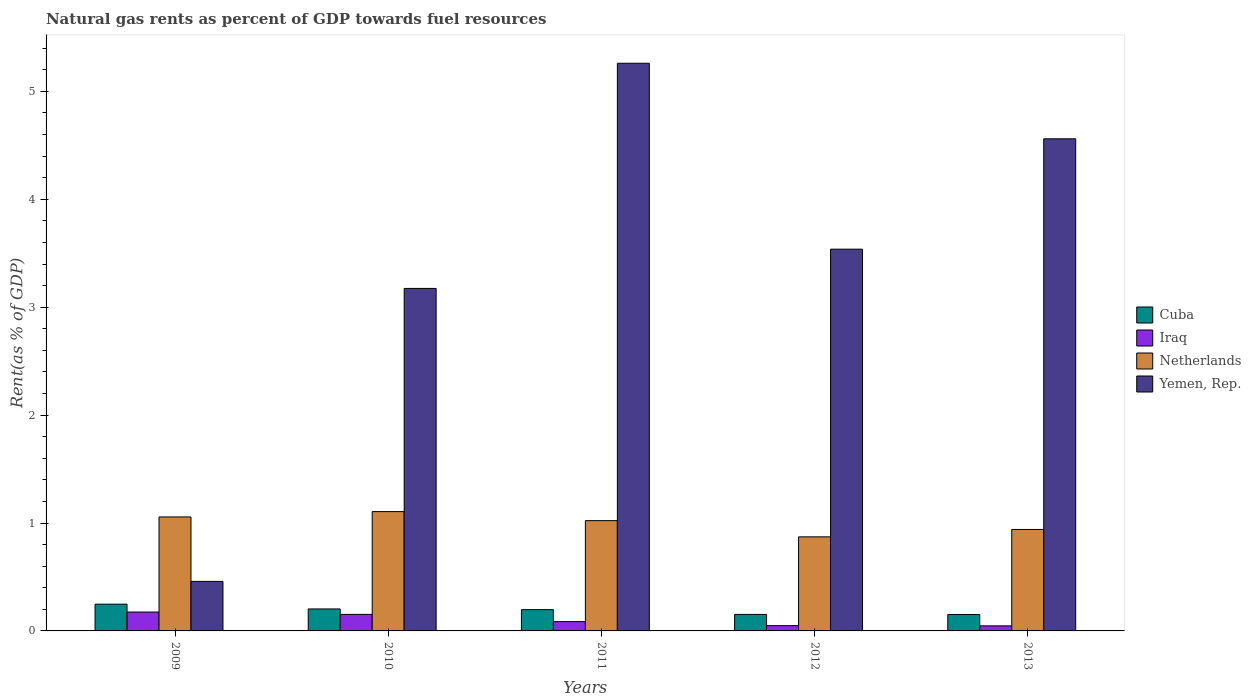How many different coloured bars are there?
Give a very brief answer. 4. How many groups of bars are there?
Ensure brevity in your answer.  5. How many bars are there on the 1st tick from the left?
Your answer should be compact. 4. How many bars are there on the 1st tick from the right?
Your answer should be compact. 4. What is the matural gas rent in Yemen, Rep. in 2011?
Ensure brevity in your answer.  5.26. Across all years, what is the maximum matural gas rent in Yemen, Rep.?
Offer a terse response. 5.26. Across all years, what is the minimum matural gas rent in Netherlands?
Your response must be concise. 0.87. In which year was the matural gas rent in Iraq maximum?
Keep it short and to the point. 2009. What is the total matural gas rent in Yemen, Rep. in the graph?
Ensure brevity in your answer.  16.99. What is the difference between the matural gas rent in Cuba in 2010 and that in 2011?
Offer a very short reply. 0.01. What is the difference between the matural gas rent in Yemen, Rep. in 2009 and the matural gas rent in Netherlands in 2013?
Offer a terse response. -0.48. What is the average matural gas rent in Iraq per year?
Offer a very short reply. 0.1. In the year 2010, what is the difference between the matural gas rent in Iraq and matural gas rent in Netherlands?
Provide a succinct answer. -0.95. In how many years, is the matural gas rent in Yemen, Rep. greater than 1.6 %?
Ensure brevity in your answer.  4. What is the ratio of the matural gas rent in Cuba in 2010 to that in 2013?
Your answer should be compact. 1.34. Is the matural gas rent in Netherlands in 2009 less than that in 2011?
Your response must be concise. No. What is the difference between the highest and the second highest matural gas rent in Netherlands?
Your answer should be compact. 0.05. What is the difference between the highest and the lowest matural gas rent in Netherlands?
Your response must be concise. 0.23. Is the sum of the matural gas rent in Iraq in 2011 and 2012 greater than the maximum matural gas rent in Yemen, Rep. across all years?
Give a very brief answer. No. Is it the case that in every year, the sum of the matural gas rent in Netherlands and matural gas rent in Iraq is greater than the sum of matural gas rent in Cuba and matural gas rent in Yemen, Rep.?
Your answer should be compact. No. What does the 1st bar from the left in 2009 represents?
Your answer should be very brief. Cuba. What does the 1st bar from the right in 2013 represents?
Give a very brief answer. Yemen, Rep. Is it the case that in every year, the sum of the matural gas rent in Iraq and matural gas rent in Cuba is greater than the matural gas rent in Yemen, Rep.?
Make the answer very short. No. Are all the bars in the graph horizontal?
Offer a very short reply. No. How many years are there in the graph?
Keep it short and to the point. 5. Are the values on the major ticks of Y-axis written in scientific E-notation?
Ensure brevity in your answer.  No. Where does the legend appear in the graph?
Keep it short and to the point. Center right. How many legend labels are there?
Keep it short and to the point. 4. What is the title of the graph?
Provide a succinct answer. Natural gas rents as percent of GDP towards fuel resources. What is the label or title of the X-axis?
Provide a succinct answer. Years. What is the label or title of the Y-axis?
Provide a short and direct response. Rent(as % of GDP). What is the Rent(as % of GDP) in Cuba in 2009?
Offer a very short reply. 0.25. What is the Rent(as % of GDP) of Iraq in 2009?
Your answer should be very brief. 0.17. What is the Rent(as % of GDP) of Netherlands in 2009?
Offer a very short reply. 1.06. What is the Rent(as % of GDP) in Yemen, Rep. in 2009?
Your answer should be compact. 0.46. What is the Rent(as % of GDP) of Cuba in 2010?
Make the answer very short. 0.2. What is the Rent(as % of GDP) of Iraq in 2010?
Give a very brief answer. 0.15. What is the Rent(as % of GDP) in Netherlands in 2010?
Your answer should be compact. 1.11. What is the Rent(as % of GDP) in Yemen, Rep. in 2010?
Provide a short and direct response. 3.17. What is the Rent(as % of GDP) in Cuba in 2011?
Your answer should be compact. 0.2. What is the Rent(as % of GDP) of Iraq in 2011?
Give a very brief answer. 0.09. What is the Rent(as % of GDP) in Netherlands in 2011?
Make the answer very short. 1.02. What is the Rent(as % of GDP) in Yemen, Rep. in 2011?
Your answer should be very brief. 5.26. What is the Rent(as % of GDP) of Cuba in 2012?
Offer a very short reply. 0.15. What is the Rent(as % of GDP) of Iraq in 2012?
Offer a terse response. 0.05. What is the Rent(as % of GDP) of Netherlands in 2012?
Give a very brief answer. 0.87. What is the Rent(as % of GDP) of Yemen, Rep. in 2012?
Provide a short and direct response. 3.54. What is the Rent(as % of GDP) in Cuba in 2013?
Your answer should be compact. 0.15. What is the Rent(as % of GDP) of Iraq in 2013?
Ensure brevity in your answer.  0.05. What is the Rent(as % of GDP) of Netherlands in 2013?
Keep it short and to the point. 0.94. What is the Rent(as % of GDP) in Yemen, Rep. in 2013?
Your response must be concise. 4.56. Across all years, what is the maximum Rent(as % of GDP) in Cuba?
Give a very brief answer. 0.25. Across all years, what is the maximum Rent(as % of GDP) in Iraq?
Provide a short and direct response. 0.17. Across all years, what is the maximum Rent(as % of GDP) in Netherlands?
Keep it short and to the point. 1.11. Across all years, what is the maximum Rent(as % of GDP) of Yemen, Rep.?
Keep it short and to the point. 5.26. Across all years, what is the minimum Rent(as % of GDP) in Cuba?
Give a very brief answer. 0.15. Across all years, what is the minimum Rent(as % of GDP) of Iraq?
Provide a succinct answer. 0.05. Across all years, what is the minimum Rent(as % of GDP) in Netherlands?
Keep it short and to the point. 0.87. Across all years, what is the minimum Rent(as % of GDP) of Yemen, Rep.?
Keep it short and to the point. 0.46. What is the total Rent(as % of GDP) in Cuba in the graph?
Offer a terse response. 0.95. What is the total Rent(as % of GDP) of Iraq in the graph?
Ensure brevity in your answer.  0.51. What is the total Rent(as % of GDP) of Netherlands in the graph?
Ensure brevity in your answer.  5. What is the total Rent(as % of GDP) in Yemen, Rep. in the graph?
Offer a very short reply. 16.99. What is the difference between the Rent(as % of GDP) in Cuba in 2009 and that in 2010?
Make the answer very short. 0.04. What is the difference between the Rent(as % of GDP) of Iraq in 2009 and that in 2010?
Provide a succinct answer. 0.02. What is the difference between the Rent(as % of GDP) in Netherlands in 2009 and that in 2010?
Give a very brief answer. -0.05. What is the difference between the Rent(as % of GDP) of Yemen, Rep. in 2009 and that in 2010?
Ensure brevity in your answer.  -2.72. What is the difference between the Rent(as % of GDP) in Cuba in 2009 and that in 2011?
Make the answer very short. 0.05. What is the difference between the Rent(as % of GDP) in Iraq in 2009 and that in 2011?
Your answer should be very brief. 0.09. What is the difference between the Rent(as % of GDP) in Netherlands in 2009 and that in 2011?
Provide a short and direct response. 0.03. What is the difference between the Rent(as % of GDP) of Yemen, Rep. in 2009 and that in 2011?
Keep it short and to the point. -4.8. What is the difference between the Rent(as % of GDP) of Cuba in 2009 and that in 2012?
Make the answer very short. 0.1. What is the difference between the Rent(as % of GDP) in Iraq in 2009 and that in 2012?
Offer a very short reply. 0.13. What is the difference between the Rent(as % of GDP) in Netherlands in 2009 and that in 2012?
Offer a terse response. 0.18. What is the difference between the Rent(as % of GDP) in Yemen, Rep. in 2009 and that in 2012?
Provide a short and direct response. -3.08. What is the difference between the Rent(as % of GDP) of Cuba in 2009 and that in 2013?
Make the answer very short. 0.1. What is the difference between the Rent(as % of GDP) in Iraq in 2009 and that in 2013?
Provide a short and direct response. 0.13. What is the difference between the Rent(as % of GDP) in Netherlands in 2009 and that in 2013?
Offer a very short reply. 0.12. What is the difference between the Rent(as % of GDP) of Yemen, Rep. in 2009 and that in 2013?
Offer a terse response. -4.1. What is the difference between the Rent(as % of GDP) in Cuba in 2010 and that in 2011?
Offer a very short reply. 0.01. What is the difference between the Rent(as % of GDP) of Iraq in 2010 and that in 2011?
Your answer should be compact. 0.07. What is the difference between the Rent(as % of GDP) in Netherlands in 2010 and that in 2011?
Provide a succinct answer. 0.08. What is the difference between the Rent(as % of GDP) in Yemen, Rep. in 2010 and that in 2011?
Offer a very short reply. -2.09. What is the difference between the Rent(as % of GDP) of Cuba in 2010 and that in 2012?
Provide a short and direct response. 0.05. What is the difference between the Rent(as % of GDP) in Iraq in 2010 and that in 2012?
Provide a short and direct response. 0.1. What is the difference between the Rent(as % of GDP) of Netherlands in 2010 and that in 2012?
Offer a very short reply. 0.23. What is the difference between the Rent(as % of GDP) in Yemen, Rep. in 2010 and that in 2012?
Ensure brevity in your answer.  -0.36. What is the difference between the Rent(as % of GDP) of Cuba in 2010 and that in 2013?
Offer a terse response. 0.05. What is the difference between the Rent(as % of GDP) of Iraq in 2010 and that in 2013?
Your response must be concise. 0.11. What is the difference between the Rent(as % of GDP) of Netherlands in 2010 and that in 2013?
Offer a very short reply. 0.17. What is the difference between the Rent(as % of GDP) of Yemen, Rep. in 2010 and that in 2013?
Your answer should be very brief. -1.39. What is the difference between the Rent(as % of GDP) in Cuba in 2011 and that in 2012?
Ensure brevity in your answer.  0.04. What is the difference between the Rent(as % of GDP) in Iraq in 2011 and that in 2012?
Keep it short and to the point. 0.04. What is the difference between the Rent(as % of GDP) of Netherlands in 2011 and that in 2012?
Make the answer very short. 0.15. What is the difference between the Rent(as % of GDP) in Yemen, Rep. in 2011 and that in 2012?
Offer a very short reply. 1.72. What is the difference between the Rent(as % of GDP) of Cuba in 2011 and that in 2013?
Keep it short and to the point. 0.05. What is the difference between the Rent(as % of GDP) of Iraq in 2011 and that in 2013?
Offer a very short reply. 0.04. What is the difference between the Rent(as % of GDP) in Netherlands in 2011 and that in 2013?
Your response must be concise. 0.08. What is the difference between the Rent(as % of GDP) in Yemen, Rep. in 2011 and that in 2013?
Provide a succinct answer. 0.7. What is the difference between the Rent(as % of GDP) of Cuba in 2012 and that in 2013?
Your answer should be very brief. 0. What is the difference between the Rent(as % of GDP) of Iraq in 2012 and that in 2013?
Ensure brevity in your answer.  0. What is the difference between the Rent(as % of GDP) in Netherlands in 2012 and that in 2013?
Your response must be concise. -0.07. What is the difference between the Rent(as % of GDP) in Yemen, Rep. in 2012 and that in 2013?
Offer a very short reply. -1.02. What is the difference between the Rent(as % of GDP) in Cuba in 2009 and the Rent(as % of GDP) in Iraq in 2010?
Offer a very short reply. 0.09. What is the difference between the Rent(as % of GDP) in Cuba in 2009 and the Rent(as % of GDP) in Netherlands in 2010?
Give a very brief answer. -0.86. What is the difference between the Rent(as % of GDP) in Cuba in 2009 and the Rent(as % of GDP) in Yemen, Rep. in 2010?
Provide a short and direct response. -2.93. What is the difference between the Rent(as % of GDP) of Iraq in 2009 and the Rent(as % of GDP) of Netherlands in 2010?
Keep it short and to the point. -0.93. What is the difference between the Rent(as % of GDP) of Iraq in 2009 and the Rent(as % of GDP) of Yemen, Rep. in 2010?
Ensure brevity in your answer.  -3. What is the difference between the Rent(as % of GDP) in Netherlands in 2009 and the Rent(as % of GDP) in Yemen, Rep. in 2010?
Your answer should be compact. -2.12. What is the difference between the Rent(as % of GDP) of Cuba in 2009 and the Rent(as % of GDP) of Iraq in 2011?
Your answer should be very brief. 0.16. What is the difference between the Rent(as % of GDP) in Cuba in 2009 and the Rent(as % of GDP) in Netherlands in 2011?
Your answer should be compact. -0.77. What is the difference between the Rent(as % of GDP) of Cuba in 2009 and the Rent(as % of GDP) of Yemen, Rep. in 2011?
Your response must be concise. -5.01. What is the difference between the Rent(as % of GDP) of Iraq in 2009 and the Rent(as % of GDP) of Netherlands in 2011?
Provide a short and direct response. -0.85. What is the difference between the Rent(as % of GDP) in Iraq in 2009 and the Rent(as % of GDP) in Yemen, Rep. in 2011?
Give a very brief answer. -5.09. What is the difference between the Rent(as % of GDP) of Netherlands in 2009 and the Rent(as % of GDP) of Yemen, Rep. in 2011?
Ensure brevity in your answer.  -4.2. What is the difference between the Rent(as % of GDP) in Cuba in 2009 and the Rent(as % of GDP) in Iraq in 2012?
Offer a terse response. 0.2. What is the difference between the Rent(as % of GDP) in Cuba in 2009 and the Rent(as % of GDP) in Netherlands in 2012?
Make the answer very short. -0.62. What is the difference between the Rent(as % of GDP) of Cuba in 2009 and the Rent(as % of GDP) of Yemen, Rep. in 2012?
Make the answer very short. -3.29. What is the difference between the Rent(as % of GDP) in Iraq in 2009 and the Rent(as % of GDP) in Netherlands in 2012?
Give a very brief answer. -0.7. What is the difference between the Rent(as % of GDP) in Iraq in 2009 and the Rent(as % of GDP) in Yemen, Rep. in 2012?
Offer a terse response. -3.36. What is the difference between the Rent(as % of GDP) in Netherlands in 2009 and the Rent(as % of GDP) in Yemen, Rep. in 2012?
Make the answer very short. -2.48. What is the difference between the Rent(as % of GDP) in Cuba in 2009 and the Rent(as % of GDP) in Iraq in 2013?
Offer a terse response. 0.2. What is the difference between the Rent(as % of GDP) of Cuba in 2009 and the Rent(as % of GDP) of Netherlands in 2013?
Make the answer very short. -0.69. What is the difference between the Rent(as % of GDP) in Cuba in 2009 and the Rent(as % of GDP) in Yemen, Rep. in 2013?
Offer a very short reply. -4.31. What is the difference between the Rent(as % of GDP) in Iraq in 2009 and the Rent(as % of GDP) in Netherlands in 2013?
Give a very brief answer. -0.77. What is the difference between the Rent(as % of GDP) in Iraq in 2009 and the Rent(as % of GDP) in Yemen, Rep. in 2013?
Ensure brevity in your answer.  -4.39. What is the difference between the Rent(as % of GDP) in Netherlands in 2009 and the Rent(as % of GDP) in Yemen, Rep. in 2013?
Provide a succinct answer. -3.5. What is the difference between the Rent(as % of GDP) of Cuba in 2010 and the Rent(as % of GDP) of Iraq in 2011?
Give a very brief answer. 0.12. What is the difference between the Rent(as % of GDP) of Cuba in 2010 and the Rent(as % of GDP) of Netherlands in 2011?
Provide a succinct answer. -0.82. What is the difference between the Rent(as % of GDP) of Cuba in 2010 and the Rent(as % of GDP) of Yemen, Rep. in 2011?
Give a very brief answer. -5.06. What is the difference between the Rent(as % of GDP) of Iraq in 2010 and the Rent(as % of GDP) of Netherlands in 2011?
Keep it short and to the point. -0.87. What is the difference between the Rent(as % of GDP) of Iraq in 2010 and the Rent(as % of GDP) of Yemen, Rep. in 2011?
Make the answer very short. -5.11. What is the difference between the Rent(as % of GDP) of Netherlands in 2010 and the Rent(as % of GDP) of Yemen, Rep. in 2011?
Your answer should be compact. -4.16. What is the difference between the Rent(as % of GDP) in Cuba in 2010 and the Rent(as % of GDP) in Iraq in 2012?
Offer a terse response. 0.15. What is the difference between the Rent(as % of GDP) of Cuba in 2010 and the Rent(as % of GDP) of Netherlands in 2012?
Offer a very short reply. -0.67. What is the difference between the Rent(as % of GDP) in Cuba in 2010 and the Rent(as % of GDP) in Yemen, Rep. in 2012?
Your answer should be very brief. -3.33. What is the difference between the Rent(as % of GDP) in Iraq in 2010 and the Rent(as % of GDP) in Netherlands in 2012?
Your answer should be very brief. -0.72. What is the difference between the Rent(as % of GDP) in Iraq in 2010 and the Rent(as % of GDP) in Yemen, Rep. in 2012?
Offer a very short reply. -3.38. What is the difference between the Rent(as % of GDP) of Netherlands in 2010 and the Rent(as % of GDP) of Yemen, Rep. in 2012?
Provide a succinct answer. -2.43. What is the difference between the Rent(as % of GDP) of Cuba in 2010 and the Rent(as % of GDP) of Iraq in 2013?
Your response must be concise. 0.16. What is the difference between the Rent(as % of GDP) of Cuba in 2010 and the Rent(as % of GDP) of Netherlands in 2013?
Provide a succinct answer. -0.74. What is the difference between the Rent(as % of GDP) in Cuba in 2010 and the Rent(as % of GDP) in Yemen, Rep. in 2013?
Ensure brevity in your answer.  -4.36. What is the difference between the Rent(as % of GDP) in Iraq in 2010 and the Rent(as % of GDP) in Netherlands in 2013?
Keep it short and to the point. -0.79. What is the difference between the Rent(as % of GDP) in Iraq in 2010 and the Rent(as % of GDP) in Yemen, Rep. in 2013?
Provide a short and direct response. -4.41. What is the difference between the Rent(as % of GDP) in Netherlands in 2010 and the Rent(as % of GDP) in Yemen, Rep. in 2013?
Provide a succinct answer. -3.45. What is the difference between the Rent(as % of GDP) in Cuba in 2011 and the Rent(as % of GDP) in Iraq in 2012?
Your response must be concise. 0.15. What is the difference between the Rent(as % of GDP) of Cuba in 2011 and the Rent(as % of GDP) of Netherlands in 2012?
Offer a very short reply. -0.67. What is the difference between the Rent(as % of GDP) of Cuba in 2011 and the Rent(as % of GDP) of Yemen, Rep. in 2012?
Keep it short and to the point. -3.34. What is the difference between the Rent(as % of GDP) of Iraq in 2011 and the Rent(as % of GDP) of Netherlands in 2012?
Your answer should be very brief. -0.79. What is the difference between the Rent(as % of GDP) in Iraq in 2011 and the Rent(as % of GDP) in Yemen, Rep. in 2012?
Give a very brief answer. -3.45. What is the difference between the Rent(as % of GDP) in Netherlands in 2011 and the Rent(as % of GDP) in Yemen, Rep. in 2012?
Keep it short and to the point. -2.52. What is the difference between the Rent(as % of GDP) in Cuba in 2011 and the Rent(as % of GDP) in Iraq in 2013?
Ensure brevity in your answer.  0.15. What is the difference between the Rent(as % of GDP) in Cuba in 2011 and the Rent(as % of GDP) in Netherlands in 2013?
Your answer should be very brief. -0.74. What is the difference between the Rent(as % of GDP) of Cuba in 2011 and the Rent(as % of GDP) of Yemen, Rep. in 2013?
Give a very brief answer. -4.36. What is the difference between the Rent(as % of GDP) in Iraq in 2011 and the Rent(as % of GDP) in Netherlands in 2013?
Offer a terse response. -0.85. What is the difference between the Rent(as % of GDP) in Iraq in 2011 and the Rent(as % of GDP) in Yemen, Rep. in 2013?
Give a very brief answer. -4.47. What is the difference between the Rent(as % of GDP) in Netherlands in 2011 and the Rent(as % of GDP) in Yemen, Rep. in 2013?
Your answer should be very brief. -3.54. What is the difference between the Rent(as % of GDP) of Cuba in 2012 and the Rent(as % of GDP) of Iraq in 2013?
Your answer should be very brief. 0.11. What is the difference between the Rent(as % of GDP) of Cuba in 2012 and the Rent(as % of GDP) of Netherlands in 2013?
Offer a terse response. -0.79. What is the difference between the Rent(as % of GDP) of Cuba in 2012 and the Rent(as % of GDP) of Yemen, Rep. in 2013?
Your answer should be compact. -4.41. What is the difference between the Rent(as % of GDP) of Iraq in 2012 and the Rent(as % of GDP) of Netherlands in 2013?
Provide a short and direct response. -0.89. What is the difference between the Rent(as % of GDP) of Iraq in 2012 and the Rent(as % of GDP) of Yemen, Rep. in 2013?
Offer a terse response. -4.51. What is the difference between the Rent(as % of GDP) of Netherlands in 2012 and the Rent(as % of GDP) of Yemen, Rep. in 2013?
Keep it short and to the point. -3.69. What is the average Rent(as % of GDP) in Cuba per year?
Your response must be concise. 0.19. What is the average Rent(as % of GDP) of Iraq per year?
Offer a very short reply. 0.1. What is the average Rent(as % of GDP) of Netherlands per year?
Provide a short and direct response. 1. What is the average Rent(as % of GDP) in Yemen, Rep. per year?
Provide a succinct answer. 3.4. In the year 2009, what is the difference between the Rent(as % of GDP) in Cuba and Rent(as % of GDP) in Iraq?
Your answer should be compact. 0.07. In the year 2009, what is the difference between the Rent(as % of GDP) of Cuba and Rent(as % of GDP) of Netherlands?
Ensure brevity in your answer.  -0.81. In the year 2009, what is the difference between the Rent(as % of GDP) in Cuba and Rent(as % of GDP) in Yemen, Rep.?
Keep it short and to the point. -0.21. In the year 2009, what is the difference between the Rent(as % of GDP) of Iraq and Rent(as % of GDP) of Netherlands?
Your answer should be compact. -0.88. In the year 2009, what is the difference between the Rent(as % of GDP) in Iraq and Rent(as % of GDP) in Yemen, Rep.?
Your answer should be compact. -0.28. In the year 2009, what is the difference between the Rent(as % of GDP) of Netherlands and Rent(as % of GDP) of Yemen, Rep.?
Your answer should be compact. 0.6. In the year 2010, what is the difference between the Rent(as % of GDP) in Cuba and Rent(as % of GDP) in Iraq?
Keep it short and to the point. 0.05. In the year 2010, what is the difference between the Rent(as % of GDP) in Cuba and Rent(as % of GDP) in Netherlands?
Provide a succinct answer. -0.9. In the year 2010, what is the difference between the Rent(as % of GDP) in Cuba and Rent(as % of GDP) in Yemen, Rep.?
Your answer should be compact. -2.97. In the year 2010, what is the difference between the Rent(as % of GDP) in Iraq and Rent(as % of GDP) in Netherlands?
Your answer should be compact. -0.95. In the year 2010, what is the difference between the Rent(as % of GDP) of Iraq and Rent(as % of GDP) of Yemen, Rep.?
Your answer should be compact. -3.02. In the year 2010, what is the difference between the Rent(as % of GDP) of Netherlands and Rent(as % of GDP) of Yemen, Rep.?
Give a very brief answer. -2.07. In the year 2011, what is the difference between the Rent(as % of GDP) in Cuba and Rent(as % of GDP) in Iraq?
Ensure brevity in your answer.  0.11. In the year 2011, what is the difference between the Rent(as % of GDP) in Cuba and Rent(as % of GDP) in Netherlands?
Offer a very short reply. -0.82. In the year 2011, what is the difference between the Rent(as % of GDP) in Cuba and Rent(as % of GDP) in Yemen, Rep.?
Give a very brief answer. -5.06. In the year 2011, what is the difference between the Rent(as % of GDP) of Iraq and Rent(as % of GDP) of Netherlands?
Your answer should be very brief. -0.94. In the year 2011, what is the difference between the Rent(as % of GDP) of Iraq and Rent(as % of GDP) of Yemen, Rep.?
Ensure brevity in your answer.  -5.17. In the year 2011, what is the difference between the Rent(as % of GDP) of Netherlands and Rent(as % of GDP) of Yemen, Rep.?
Your answer should be very brief. -4.24. In the year 2012, what is the difference between the Rent(as % of GDP) of Cuba and Rent(as % of GDP) of Iraq?
Provide a short and direct response. 0.1. In the year 2012, what is the difference between the Rent(as % of GDP) of Cuba and Rent(as % of GDP) of Netherlands?
Your answer should be very brief. -0.72. In the year 2012, what is the difference between the Rent(as % of GDP) in Cuba and Rent(as % of GDP) in Yemen, Rep.?
Give a very brief answer. -3.39. In the year 2012, what is the difference between the Rent(as % of GDP) of Iraq and Rent(as % of GDP) of Netherlands?
Offer a terse response. -0.82. In the year 2012, what is the difference between the Rent(as % of GDP) in Iraq and Rent(as % of GDP) in Yemen, Rep.?
Offer a very short reply. -3.49. In the year 2012, what is the difference between the Rent(as % of GDP) in Netherlands and Rent(as % of GDP) in Yemen, Rep.?
Your answer should be compact. -2.67. In the year 2013, what is the difference between the Rent(as % of GDP) in Cuba and Rent(as % of GDP) in Iraq?
Your answer should be very brief. 0.1. In the year 2013, what is the difference between the Rent(as % of GDP) of Cuba and Rent(as % of GDP) of Netherlands?
Provide a succinct answer. -0.79. In the year 2013, what is the difference between the Rent(as % of GDP) of Cuba and Rent(as % of GDP) of Yemen, Rep.?
Offer a very short reply. -4.41. In the year 2013, what is the difference between the Rent(as % of GDP) in Iraq and Rent(as % of GDP) in Netherlands?
Your response must be concise. -0.89. In the year 2013, what is the difference between the Rent(as % of GDP) of Iraq and Rent(as % of GDP) of Yemen, Rep.?
Your answer should be very brief. -4.51. In the year 2013, what is the difference between the Rent(as % of GDP) in Netherlands and Rent(as % of GDP) in Yemen, Rep.?
Provide a succinct answer. -3.62. What is the ratio of the Rent(as % of GDP) of Cuba in 2009 to that in 2010?
Provide a short and direct response. 1.22. What is the ratio of the Rent(as % of GDP) of Iraq in 2009 to that in 2010?
Offer a terse response. 1.14. What is the ratio of the Rent(as % of GDP) in Netherlands in 2009 to that in 2010?
Provide a short and direct response. 0.96. What is the ratio of the Rent(as % of GDP) of Yemen, Rep. in 2009 to that in 2010?
Give a very brief answer. 0.14. What is the ratio of the Rent(as % of GDP) in Cuba in 2009 to that in 2011?
Give a very brief answer. 1.26. What is the ratio of the Rent(as % of GDP) of Iraq in 2009 to that in 2011?
Your answer should be compact. 2.02. What is the ratio of the Rent(as % of GDP) in Netherlands in 2009 to that in 2011?
Keep it short and to the point. 1.03. What is the ratio of the Rent(as % of GDP) in Yemen, Rep. in 2009 to that in 2011?
Your response must be concise. 0.09. What is the ratio of the Rent(as % of GDP) of Cuba in 2009 to that in 2012?
Provide a succinct answer. 1.62. What is the ratio of the Rent(as % of GDP) of Iraq in 2009 to that in 2012?
Give a very brief answer. 3.57. What is the ratio of the Rent(as % of GDP) of Netherlands in 2009 to that in 2012?
Your answer should be compact. 1.21. What is the ratio of the Rent(as % of GDP) in Yemen, Rep. in 2009 to that in 2012?
Ensure brevity in your answer.  0.13. What is the ratio of the Rent(as % of GDP) in Cuba in 2009 to that in 2013?
Keep it short and to the point. 1.63. What is the ratio of the Rent(as % of GDP) of Iraq in 2009 to that in 2013?
Keep it short and to the point. 3.72. What is the ratio of the Rent(as % of GDP) in Netherlands in 2009 to that in 2013?
Make the answer very short. 1.12. What is the ratio of the Rent(as % of GDP) in Yemen, Rep. in 2009 to that in 2013?
Your answer should be compact. 0.1. What is the ratio of the Rent(as % of GDP) of Cuba in 2010 to that in 2011?
Provide a succinct answer. 1.03. What is the ratio of the Rent(as % of GDP) of Iraq in 2010 to that in 2011?
Offer a very short reply. 1.77. What is the ratio of the Rent(as % of GDP) of Netherlands in 2010 to that in 2011?
Keep it short and to the point. 1.08. What is the ratio of the Rent(as % of GDP) in Yemen, Rep. in 2010 to that in 2011?
Offer a very short reply. 0.6. What is the ratio of the Rent(as % of GDP) in Cuba in 2010 to that in 2012?
Make the answer very short. 1.33. What is the ratio of the Rent(as % of GDP) in Iraq in 2010 to that in 2012?
Offer a terse response. 3.13. What is the ratio of the Rent(as % of GDP) in Netherlands in 2010 to that in 2012?
Provide a short and direct response. 1.27. What is the ratio of the Rent(as % of GDP) in Yemen, Rep. in 2010 to that in 2012?
Your response must be concise. 0.9. What is the ratio of the Rent(as % of GDP) in Cuba in 2010 to that in 2013?
Offer a terse response. 1.34. What is the ratio of the Rent(as % of GDP) of Iraq in 2010 to that in 2013?
Provide a succinct answer. 3.26. What is the ratio of the Rent(as % of GDP) of Netherlands in 2010 to that in 2013?
Your answer should be very brief. 1.18. What is the ratio of the Rent(as % of GDP) of Yemen, Rep. in 2010 to that in 2013?
Your response must be concise. 0.7. What is the ratio of the Rent(as % of GDP) in Cuba in 2011 to that in 2012?
Your answer should be very brief. 1.29. What is the ratio of the Rent(as % of GDP) of Iraq in 2011 to that in 2012?
Your response must be concise. 1.76. What is the ratio of the Rent(as % of GDP) of Netherlands in 2011 to that in 2012?
Your answer should be very brief. 1.17. What is the ratio of the Rent(as % of GDP) of Yemen, Rep. in 2011 to that in 2012?
Your answer should be compact. 1.49. What is the ratio of the Rent(as % of GDP) of Cuba in 2011 to that in 2013?
Make the answer very short. 1.3. What is the ratio of the Rent(as % of GDP) of Iraq in 2011 to that in 2013?
Offer a terse response. 1.84. What is the ratio of the Rent(as % of GDP) of Netherlands in 2011 to that in 2013?
Give a very brief answer. 1.09. What is the ratio of the Rent(as % of GDP) of Yemen, Rep. in 2011 to that in 2013?
Keep it short and to the point. 1.15. What is the ratio of the Rent(as % of GDP) of Cuba in 2012 to that in 2013?
Ensure brevity in your answer.  1.01. What is the ratio of the Rent(as % of GDP) of Iraq in 2012 to that in 2013?
Make the answer very short. 1.04. What is the ratio of the Rent(as % of GDP) in Netherlands in 2012 to that in 2013?
Your answer should be very brief. 0.93. What is the ratio of the Rent(as % of GDP) of Yemen, Rep. in 2012 to that in 2013?
Make the answer very short. 0.78. What is the difference between the highest and the second highest Rent(as % of GDP) of Cuba?
Keep it short and to the point. 0.04. What is the difference between the highest and the second highest Rent(as % of GDP) of Iraq?
Make the answer very short. 0.02. What is the difference between the highest and the second highest Rent(as % of GDP) of Netherlands?
Your response must be concise. 0.05. What is the difference between the highest and the second highest Rent(as % of GDP) in Yemen, Rep.?
Keep it short and to the point. 0.7. What is the difference between the highest and the lowest Rent(as % of GDP) in Cuba?
Offer a very short reply. 0.1. What is the difference between the highest and the lowest Rent(as % of GDP) in Iraq?
Make the answer very short. 0.13. What is the difference between the highest and the lowest Rent(as % of GDP) in Netherlands?
Your answer should be very brief. 0.23. What is the difference between the highest and the lowest Rent(as % of GDP) of Yemen, Rep.?
Keep it short and to the point. 4.8. 